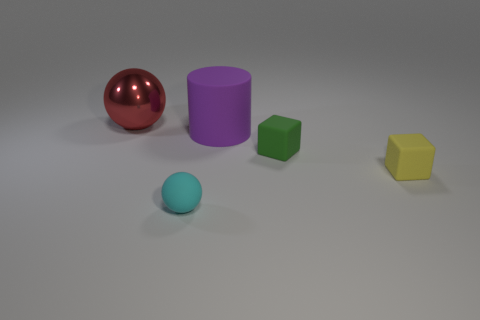Add 2 small rubber cubes. How many objects exist? 7 Subtract all cylinders. How many objects are left? 4 Subtract all large blue things. Subtract all big purple matte objects. How many objects are left? 4 Add 4 large purple matte objects. How many large purple matte objects are left? 5 Add 3 purple matte cylinders. How many purple matte cylinders exist? 4 Subtract 0 blue spheres. How many objects are left? 5 